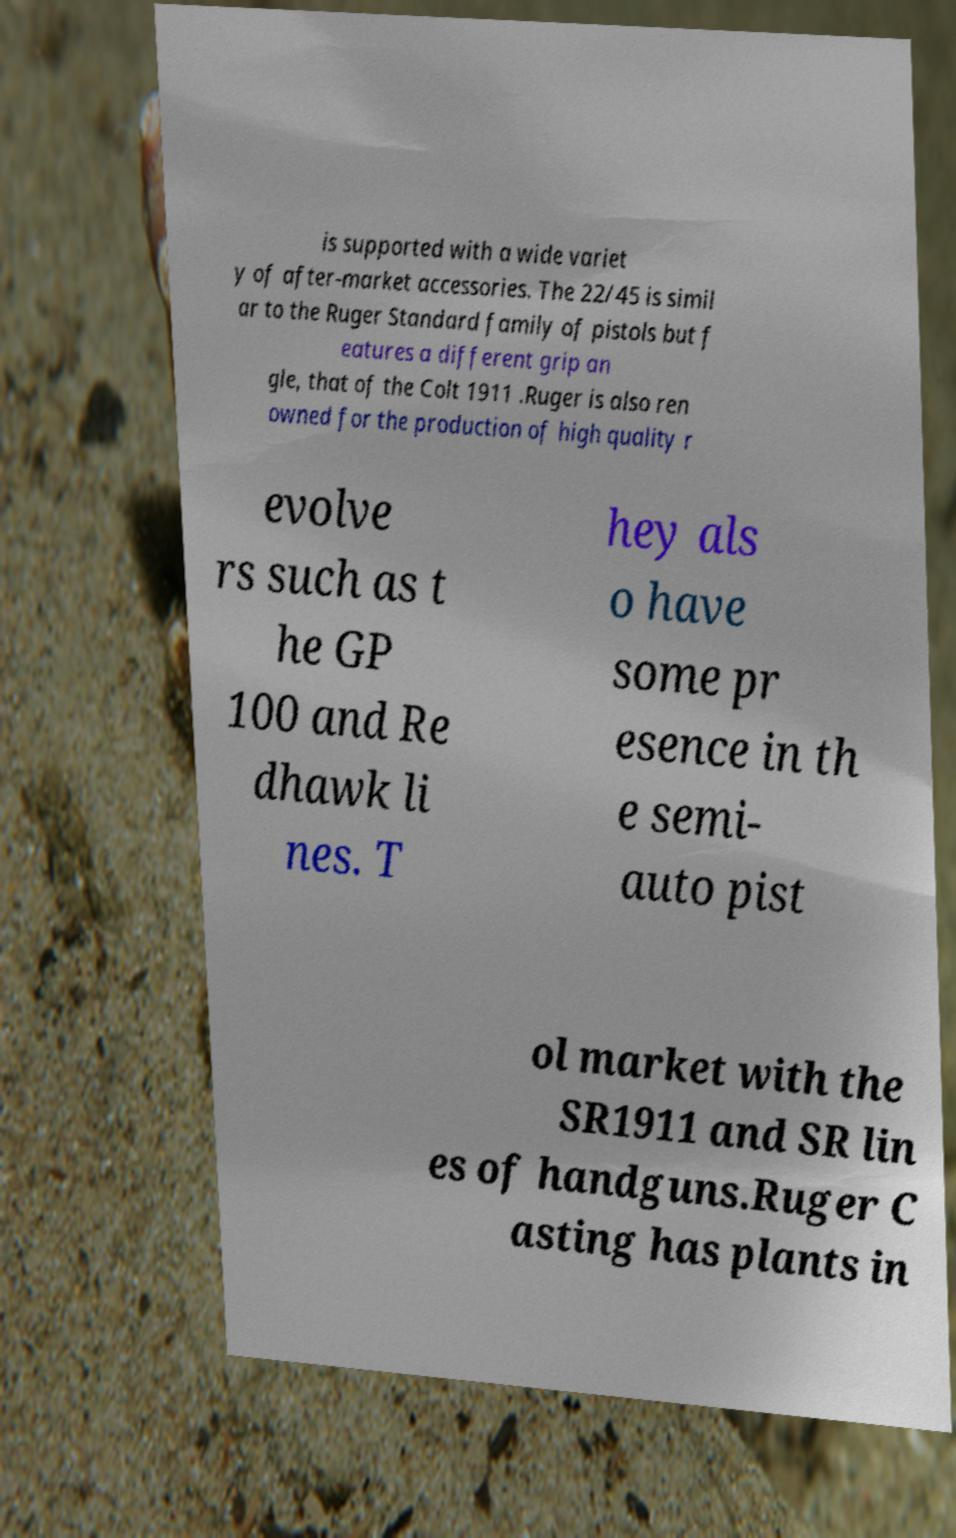For documentation purposes, I need the text within this image transcribed. Could you provide that? is supported with a wide variet y of after-market accessories. The 22/45 is simil ar to the Ruger Standard family of pistols but f eatures a different grip an gle, that of the Colt 1911 .Ruger is also ren owned for the production of high quality r evolve rs such as t he GP 100 and Re dhawk li nes. T hey als o have some pr esence in th e semi- auto pist ol market with the SR1911 and SR lin es of handguns.Ruger C asting has plants in 